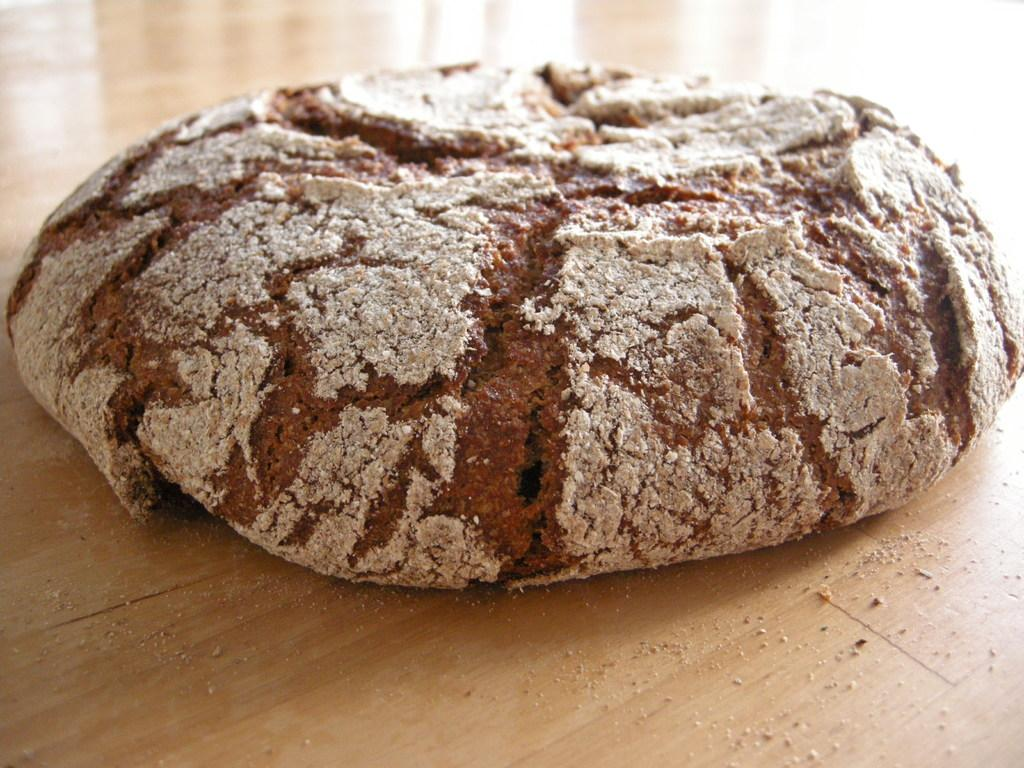What is the main subject in the image? There is an object in the image. Where is the object located? The object is placed on a table. What type of shoe is visible on the territory in the image? There is no shoe or territory present in the image; it only features an object placed on a table. 